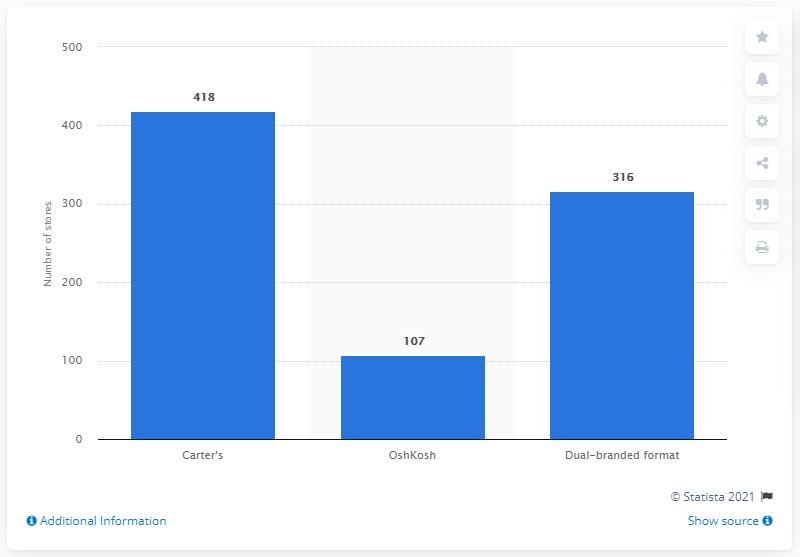Specify some key components in this picture. In 2018, Carter's, Inc. operated a total of 418 stand-alone stores. 